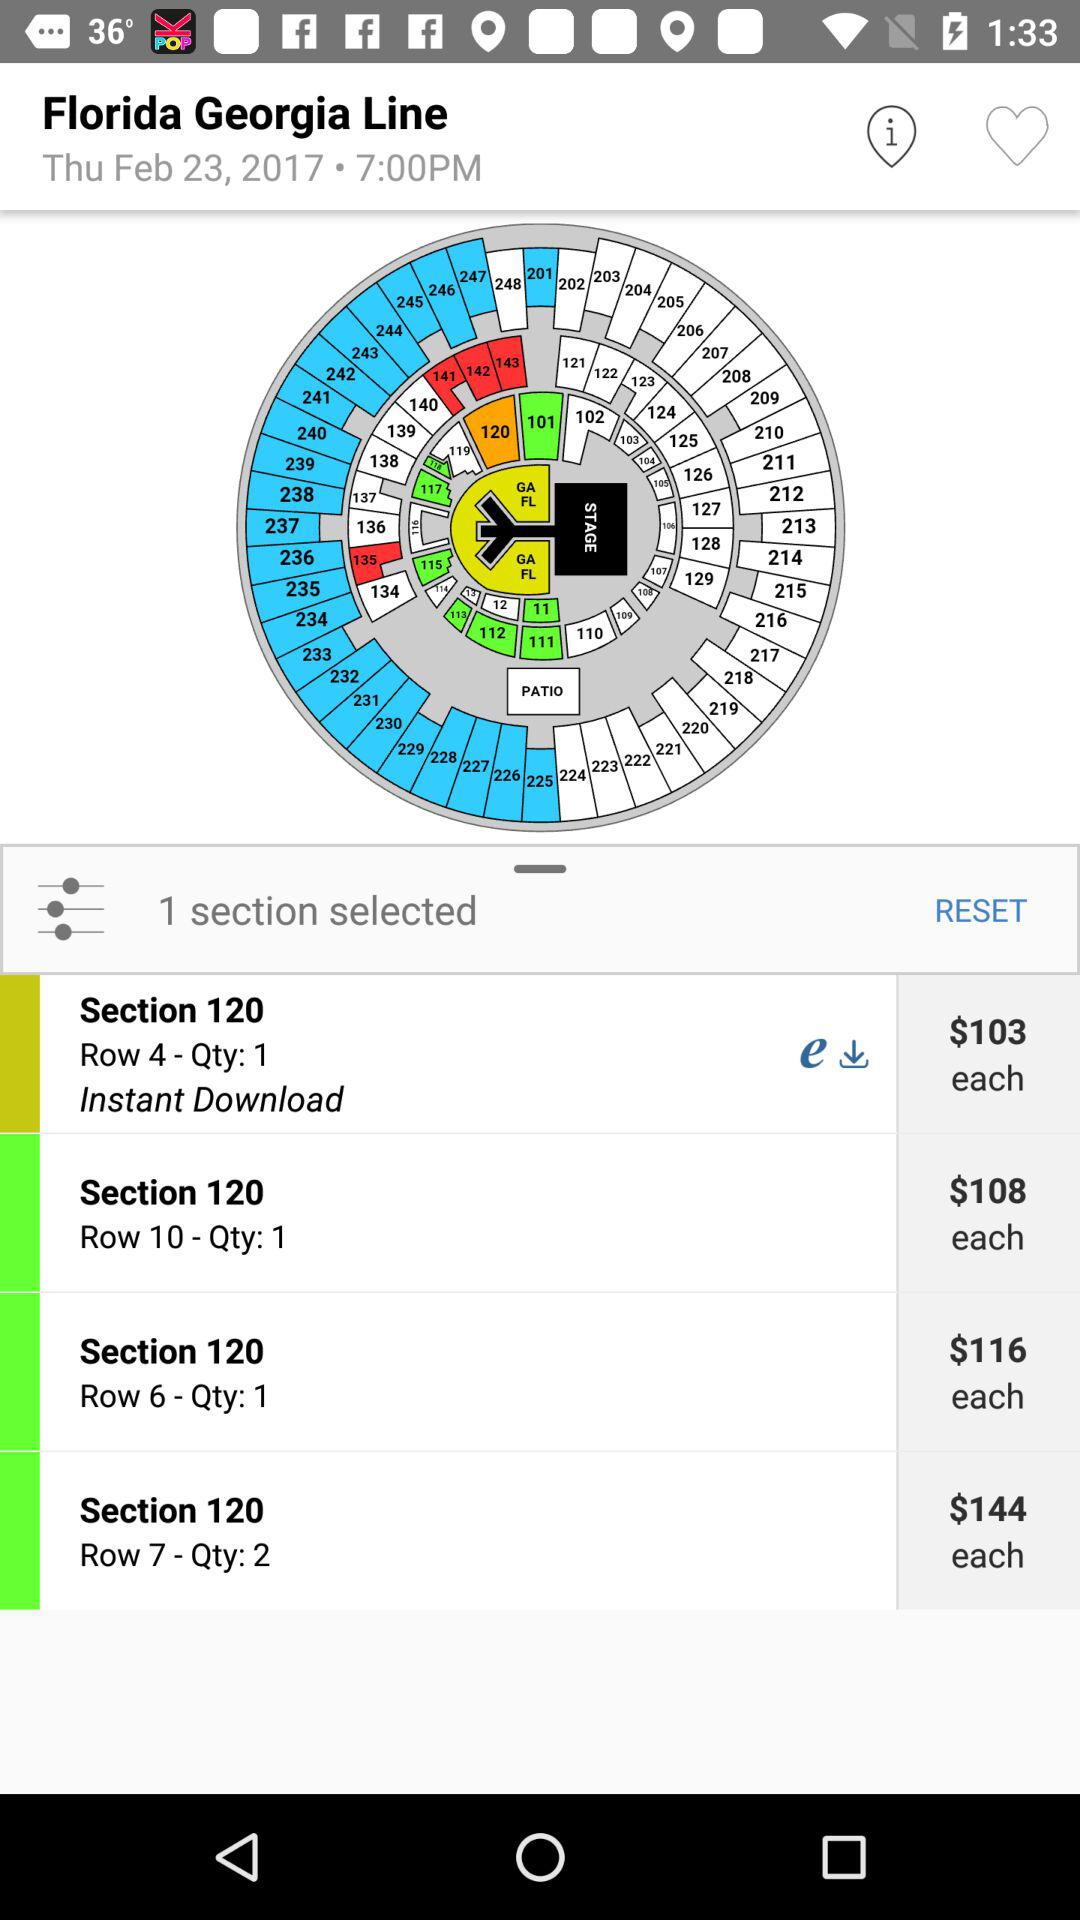What is the mentioned date? The mentioned date is Thursday, February 23, 2017. 